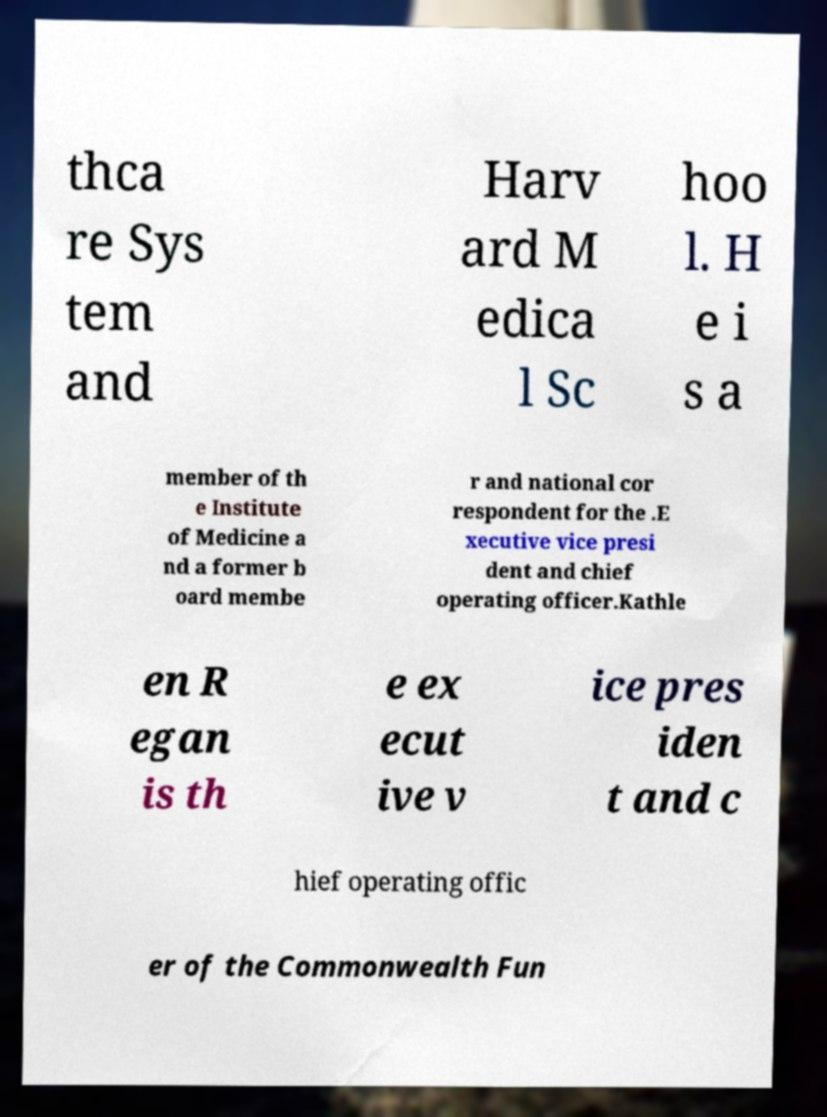For documentation purposes, I need the text within this image transcribed. Could you provide that? thca re Sys tem and Harv ard M edica l Sc hoo l. H e i s a member of th e Institute of Medicine a nd a former b oard membe r and national cor respondent for the .E xecutive vice presi dent and chief operating officer.Kathle en R egan is th e ex ecut ive v ice pres iden t and c hief operating offic er of the Commonwealth Fun 